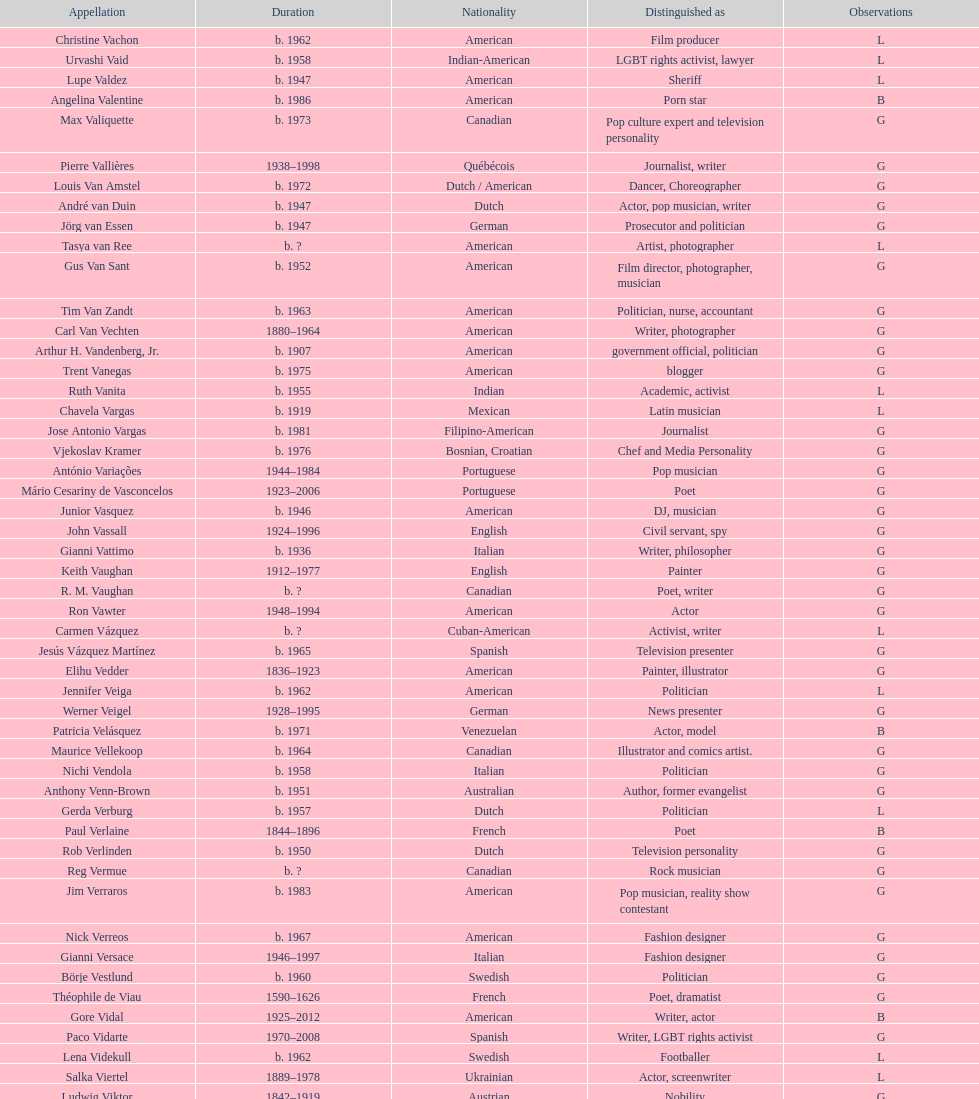Which nation has the most significant number of people linked to it? American. 